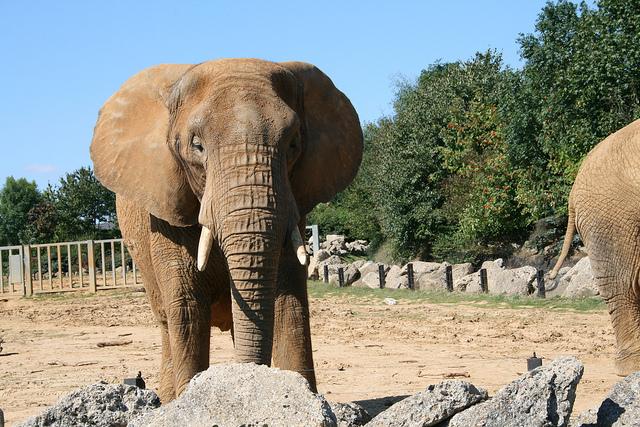What is the white things growing on the elephant?
Write a very short answer. Tusks. What is in front of the elephant?
Short answer required. Rocks. What color is this elephant?
Quick response, please. Brown. 